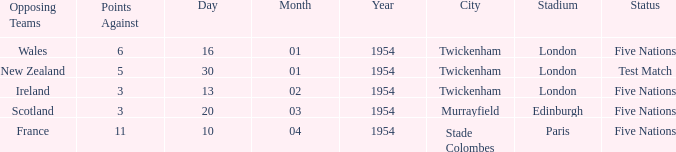In which venue was there an against of 11? Stade Colombes , Paris. 